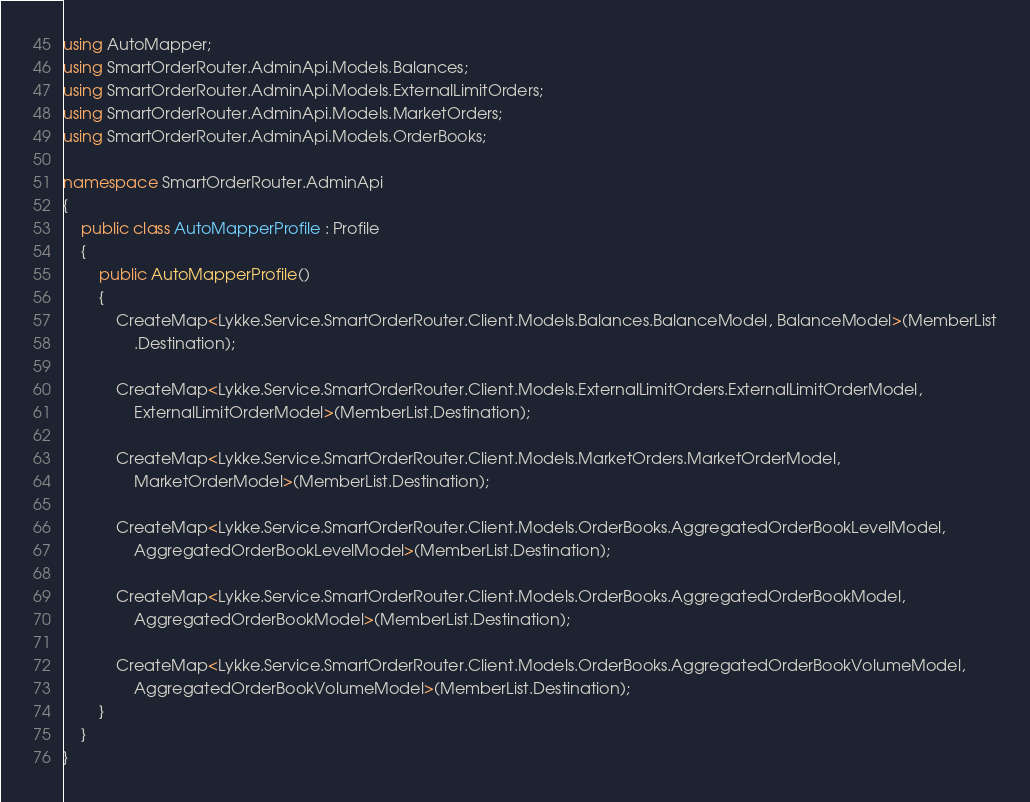Convert code to text. <code><loc_0><loc_0><loc_500><loc_500><_C#_>using AutoMapper;
using SmartOrderRouter.AdminApi.Models.Balances;
using SmartOrderRouter.AdminApi.Models.ExternalLimitOrders;
using SmartOrderRouter.AdminApi.Models.MarketOrders;
using SmartOrderRouter.AdminApi.Models.OrderBooks;

namespace SmartOrderRouter.AdminApi
{
    public class AutoMapperProfile : Profile
    {
        public AutoMapperProfile()
        {
            CreateMap<Lykke.Service.SmartOrderRouter.Client.Models.Balances.BalanceModel, BalanceModel>(MemberList
                .Destination);

            CreateMap<Lykke.Service.SmartOrderRouter.Client.Models.ExternalLimitOrders.ExternalLimitOrderModel,
                ExternalLimitOrderModel>(MemberList.Destination);

            CreateMap<Lykke.Service.SmartOrderRouter.Client.Models.MarketOrders.MarketOrderModel,
                MarketOrderModel>(MemberList.Destination);

            CreateMap<Lykke.Service.SmartOrderRouter.Client.Models.OrderBooks.AggregatedOrderBookLevelModel,
                AggregatedOrderBookLevelModel>(MemberList.Destination);

            CreateMap<Lykke.Service.SmartOrderRouter.Client.Models.OrderBooks.AggregatedOrderBookModel,
                AggregatedOrderBookModel>(MemberList.Destination);

            CreateMap<Lykke.Service.SmartOrderRouter.Client.Models.OrderBooks.AggregatedOrderBookVolumeModel,
                AggregatedOrderBookVolumeModel>(MemberList.Destination);
        }
    }
}
</code> 